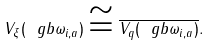Convert formula to latex. <formula><loc_0><loc_0><loc_500><loc_500>V _ { \xi } ( \ g b \omega _ { i , a } ) \cong \overline { V _ { q } ( \ g b \omega _ { i , a } ) } .</formula> 